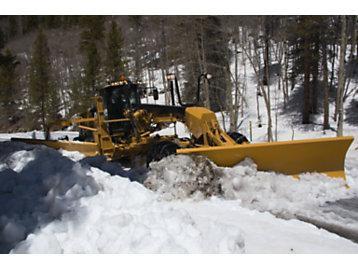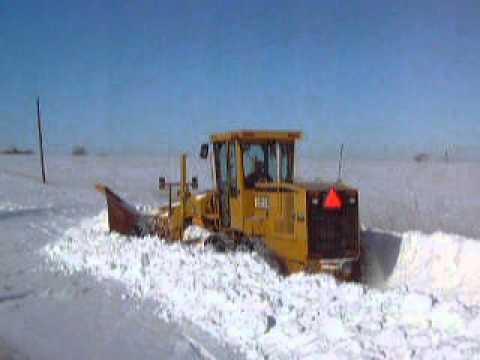The first image is the image on the left, the second image is the image on the right. Given the left and right images, does the statement "The equipment in both images is yellow, but one is parked on a snowy surface, while the other is not." hold true? Answer yes or no. No. 